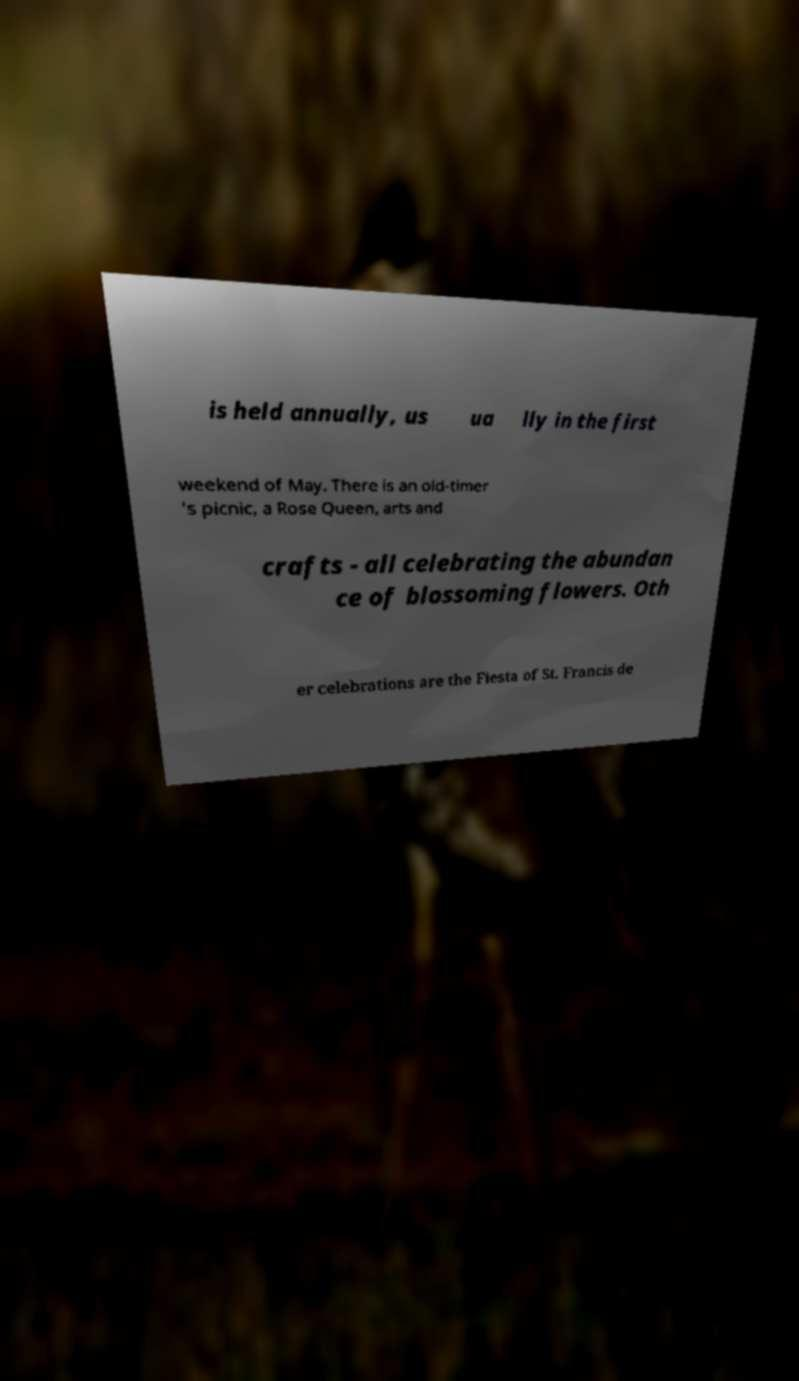Could you assist in decoding the text presented in this image and type it out clearly? is held annually, us ua lly in the first weekend of May. There is an old-timer 's picnic, a Rose Queen, arts and crafts - all celebrating the abundan ce of blossoming flowers. Oth er celebrations are the Fiesta of St. Francis de 